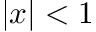Convert formula to latex. <formula><loc_0><loc_0><loc_500><loc_500>| x | < 1</formula> 